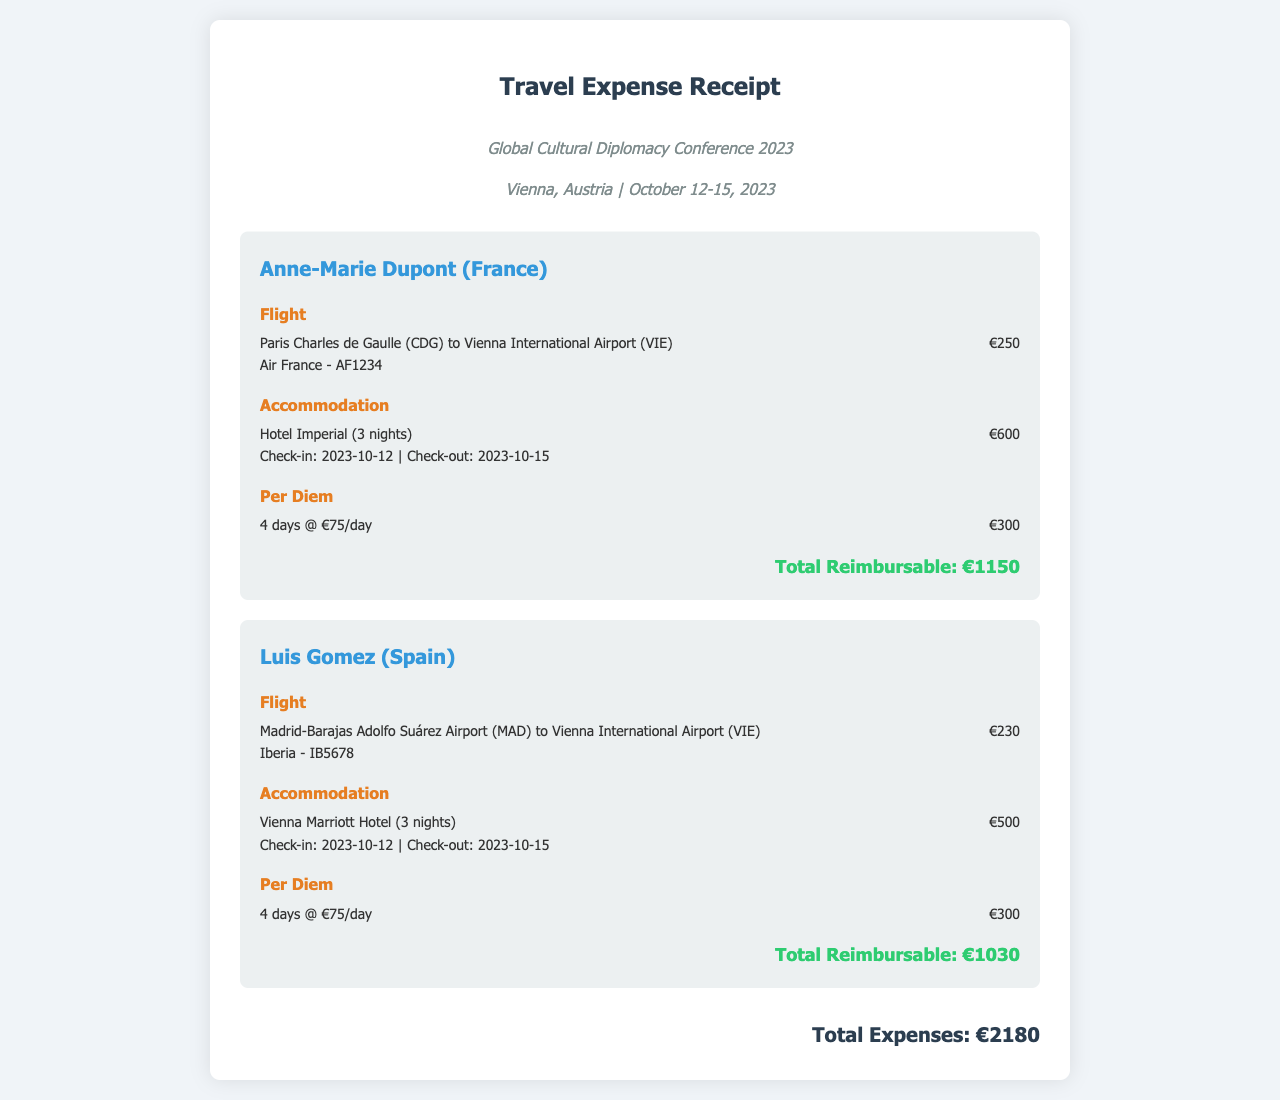What is the conference name? The conference name is stated at the top of the document under the conference info section.
Answer: Global Cultural Diplomacy Conference 2023 Where is the conference held? The location of the conference is mentioned in the conference info section of the document.
Answer: Vienna, Austria What are the dates of the conference? The dates for the conference are specified in the conference info section.
Answer: October 12-15, 2023 What is the total reimbursable amount for Anne-Marie Dupont? The total reimbursable amount for each delegate is provided at the end of their respective sections.
Answer: €1150 How much was Luis Gomez's flight? The flight cost for each delegate is listed in the flight expense category.
Answer: €230 How many nights did Anne-Marie Dupont stay? The number of nights stayed is detailed in the accommodation expense category.
Answer: 3 nights What is the per diem rate per day? The per diem rate is mentioned in the per diem expense section for each delegate.
Answer: €75/day What is the grand total of all expenses? The grand total represents the sum of all delegates' expenditures and is displayed at the bottom of the document.
Answer: €2180 What airline did Anne-Marie Dupont take? The airline information is provided in the details under the flight expense category.
Answer: Air France 